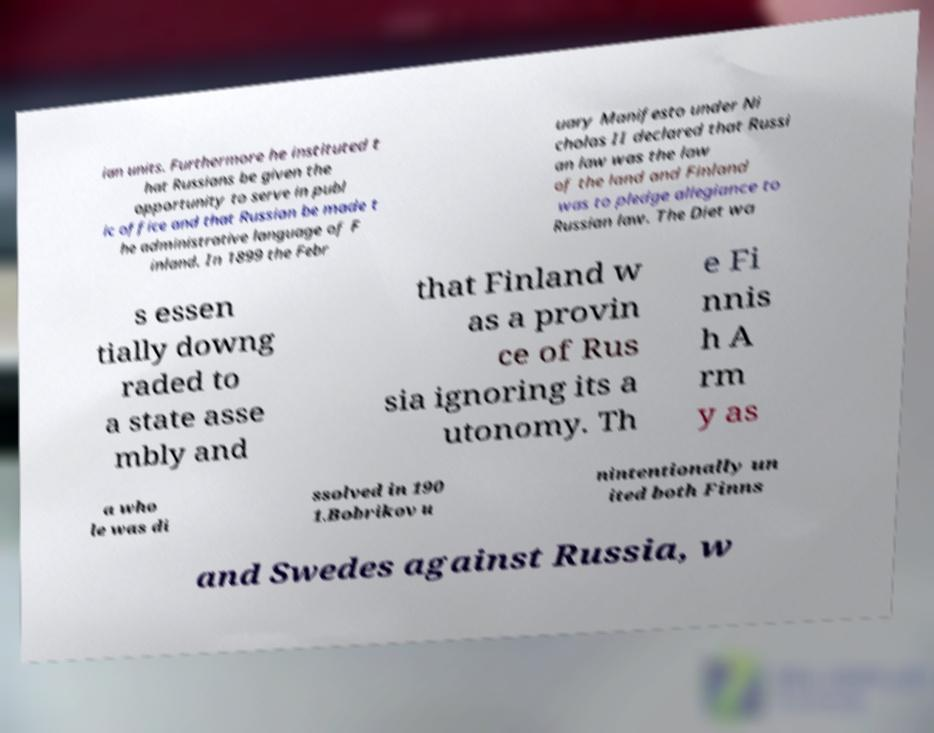Can you accurately transcribe the text from the provided image for me? ian units. Furthermore he instituted t hat Russians be given the opportunity to serve in publ ic office and that Russian be made t he administrative language of F inland. In 1899 the Febr uary Manifesto under Ni cholas II declared that Russi an law was the law of the land and Finland was to pledge allegiance to Russian law. The Diet wa s essen tially downg raded to a state asse mbly and that Finland w as a provin ce of Rus sia ignoring its a utonomy. Th e Fi nnis h A rm y as a who le was di ssolved in 190 1.Bobrikov u nintentionally un ited both Finns and Swedes against Russia, w 